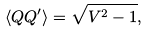<formula> <loc_0><loc_0><loc_500><loc_500>\left \langle { Q Q ^ { \prime } } \right \rangle = \sqrt { V ^ { 2 } - 1 } ,</formula> 